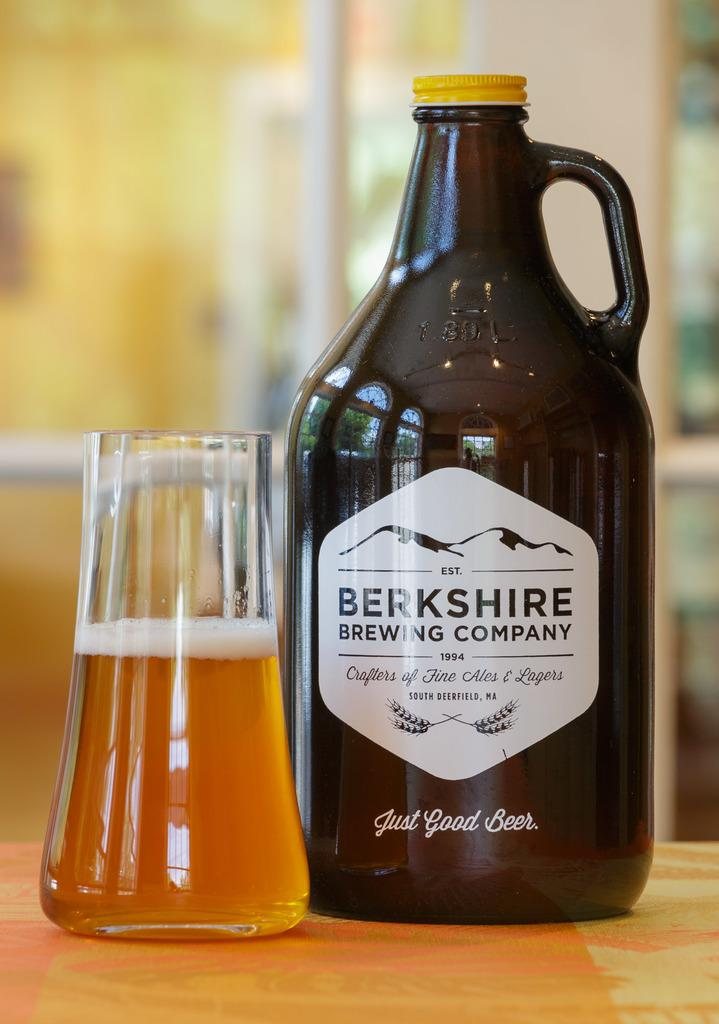<image>
Provide a brief description of the given image. A brown bottle of Berkshire Brewing Company Ale next to a half full drinking glass. 